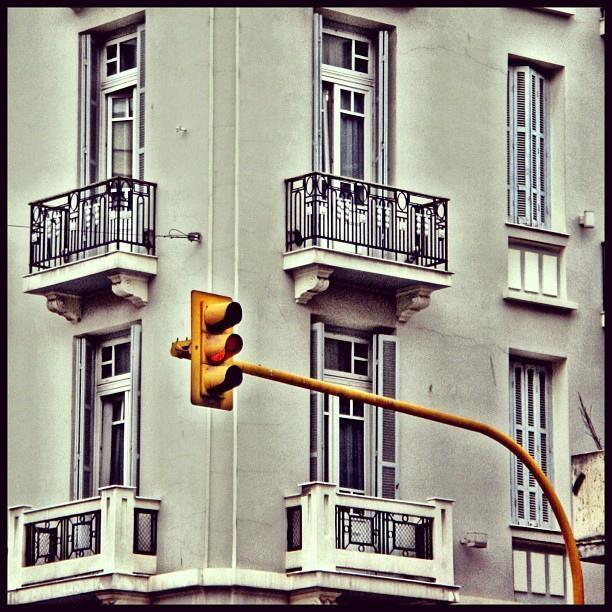How many windows are shown?
Give a very brief answer. 6. How many people will be sharing the pizza?
Give a very brief answer. 0. 